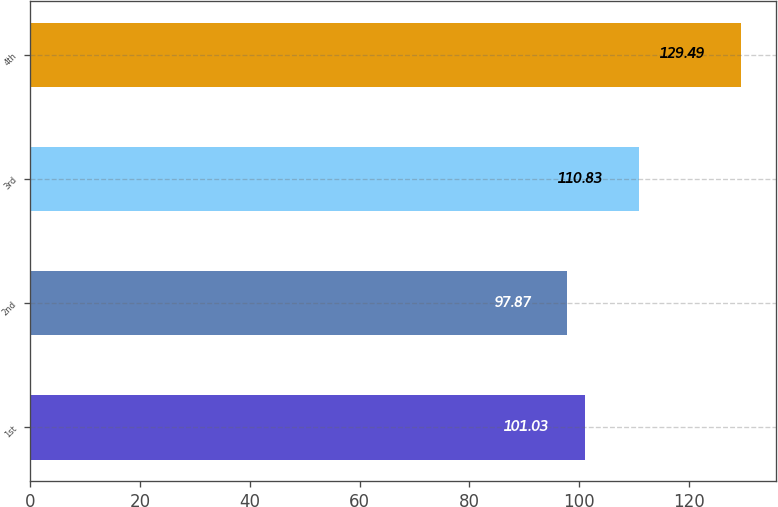<chart> <loc_0><loc_0><loc_500><loc_500><bar_chart><fcel>1st<fcel>2nd<fcel>3rd<fcel>4th<nl><fcel>101.03<fcel>97.87<fcel>110.83<fcel>129.49<nl></chart> 